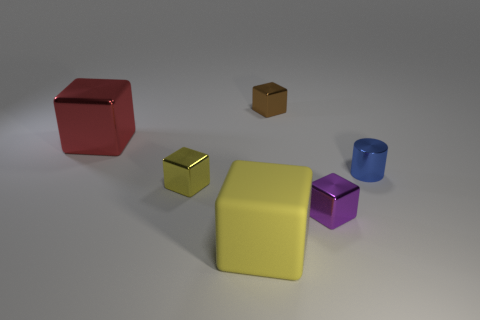Are there the same number of large shiny objects that are left of the small brown metal thing and large rubber objects behind the large red metal cube?
Make the answer very short. No. Are there any large metal things behind the tiny shiny object behind the tiny metal object right of the small purple object?
Offer a terse response. No. Do the red shiny object and the brown thing have the same size?
Your response must be concise. No. What is the color of the rubber thing in front of the tiny cube that is to the right of the tiny cube behind the blue metal thing?
Offer a very short reply. Yellow. How many tiny metal things have the same color as the large rubber thing?
Provide a succinct answer. 1. How many big objects are either blocks or metal objects?
Offer a terse response. 2. Is there a cyan matte object that has the same shape as the blue thing?
Give a very brief answer. No. Does the large rubber thing have the same shape as the large red thing?
Keep it short and to the point. Yes. What color is the large block in front of the tiny object in front of the small yellow block?
Your answer should be very brief. Yellow. There is another block that is the same size as the yellow rubber block; what color is it?
Your answer should be compact. Red. 